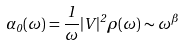<formula> <loc_0><loc_0><loc_500><loc_500>\alpha _ { 0 } ( \omega ) = \frac { 1 } { \omega } | V | ^ { 2 } \rho ( \omega ) \sim \omega ^ { \beta }</formula> 